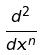<formula> <loc_0><loc_0><loc_500><loc_500>\frac { d ^ { 2 } } { d x ^ { n } }</formula> 